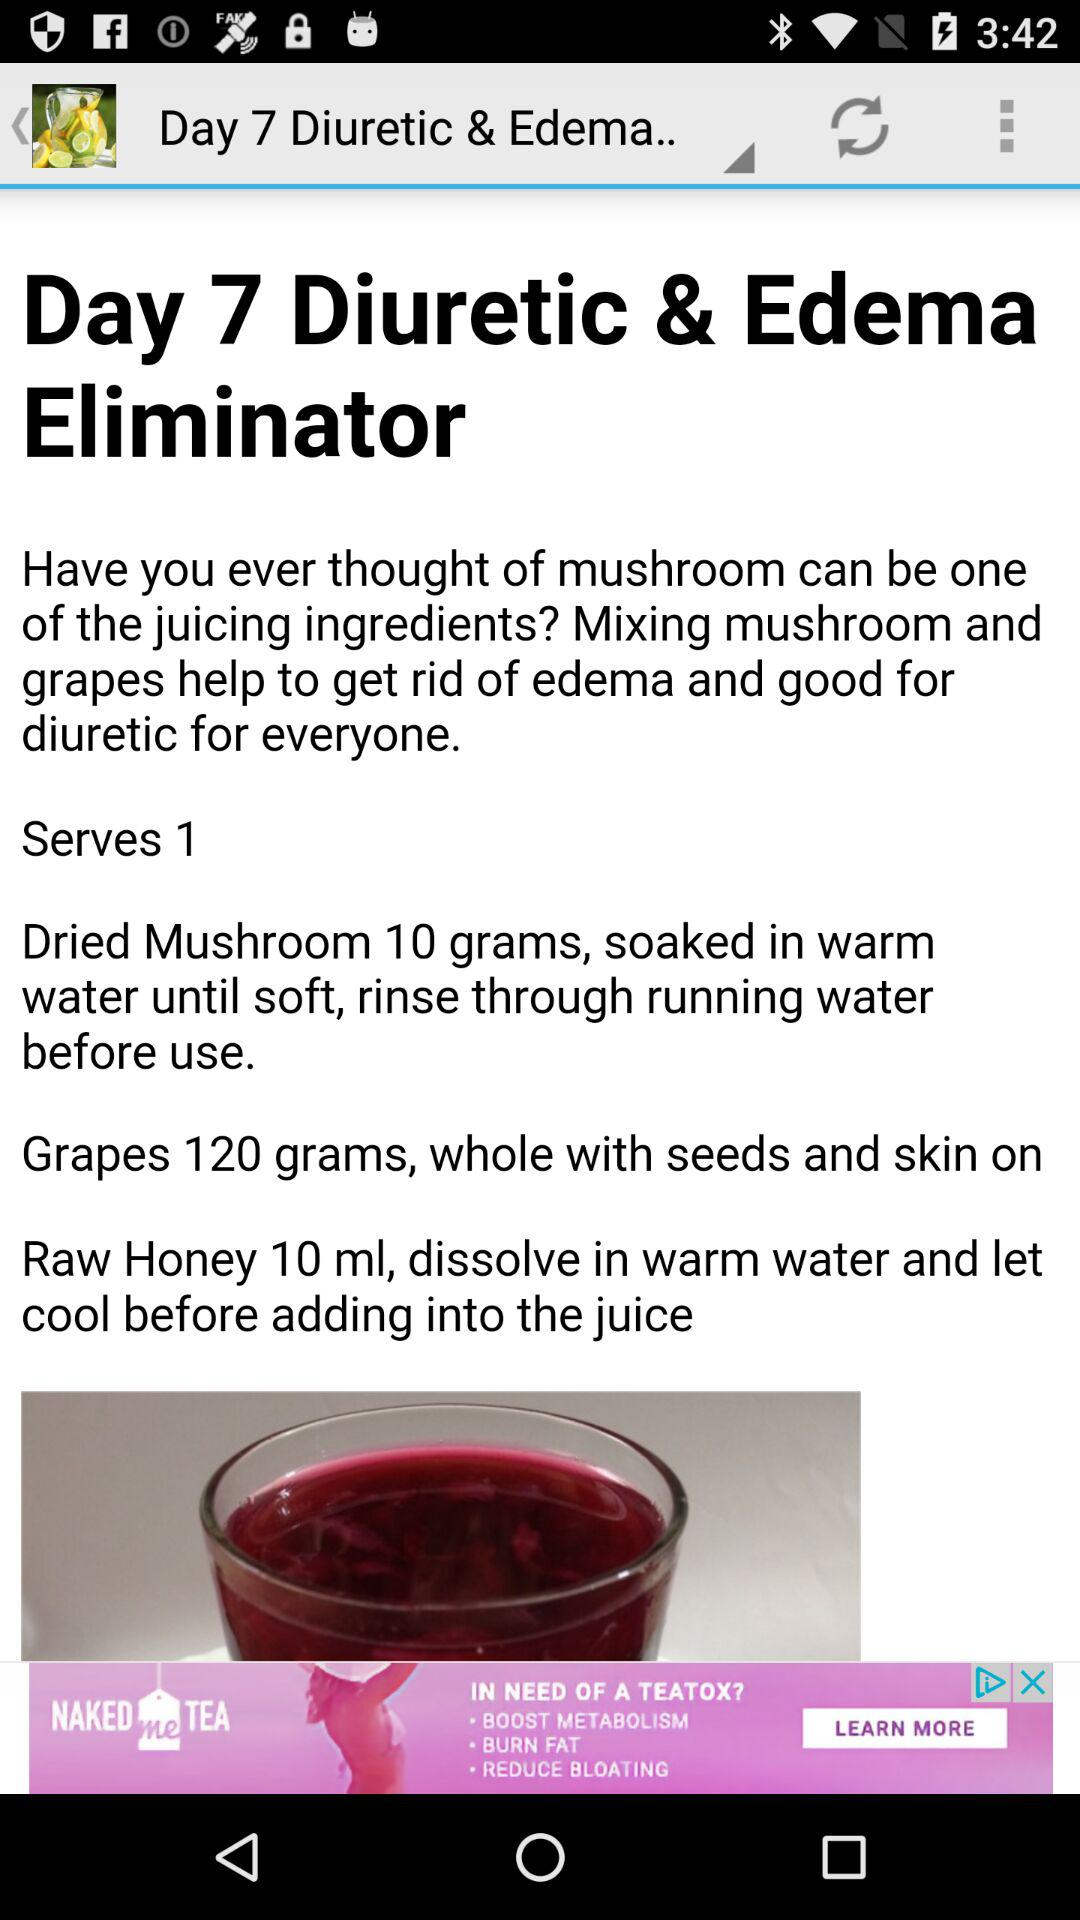How many more grams of grapes are used than mushroom?
Answer the question using a single word or phrase. 110 